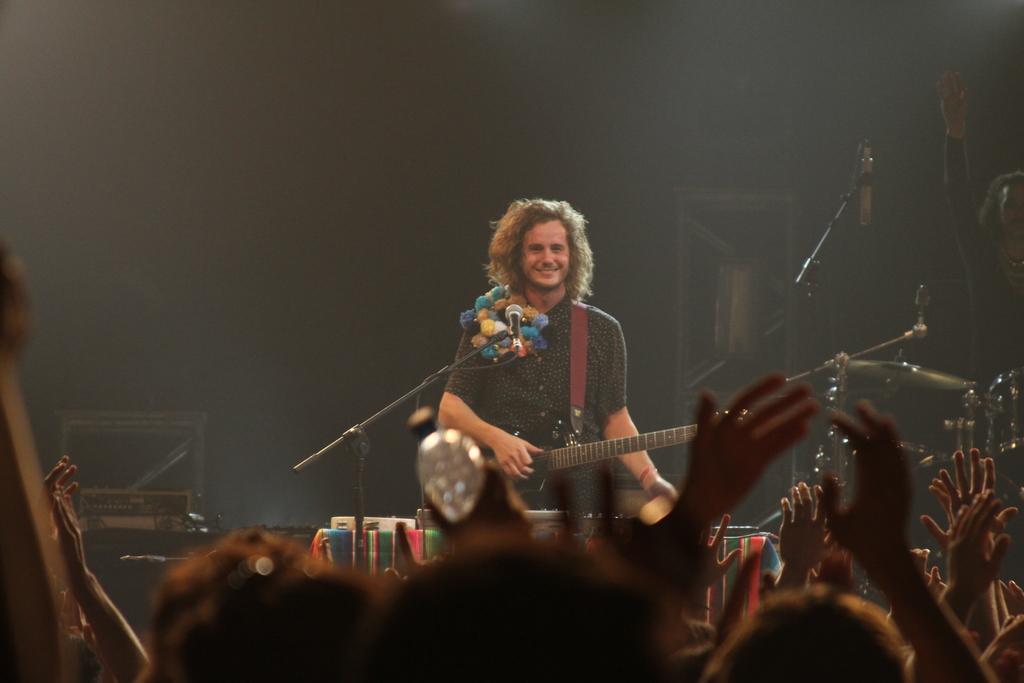Can you describe this image briefly? In this image I can see a person standing in front of the mic and holding the guitar. And the group of people are seeing this person. 